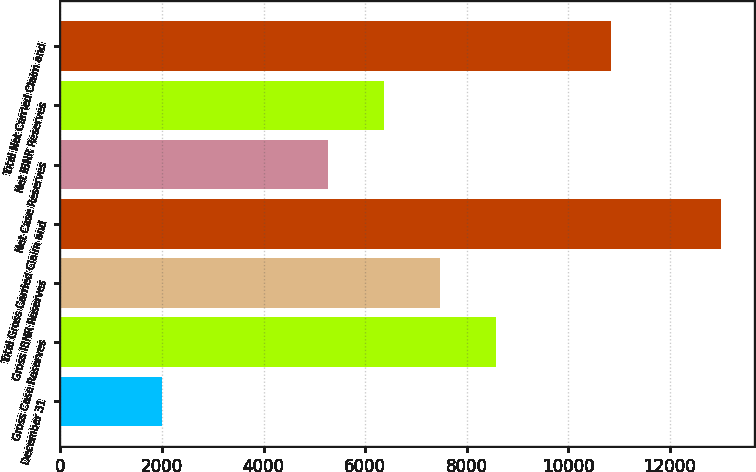Convert chart to OTSL. <chart><loc_0><loc_0><loc_500><loc_500><bar_chart><fcel>December 31<fcel>Gross Case Reserves<fcel>Gross IBNR Reserves<fcel>Total Gross Carried Claim and<fcel>Net Case Reserves<fcel>Net IBNR Reserves<fcel>Total Net Carried Claim and<nl><fcel>2009<fcel>8567.8<fcel>7468.2<fcel>13005<fcel>5269<fcel>6368.6<fcel>10849<nl></chart> 